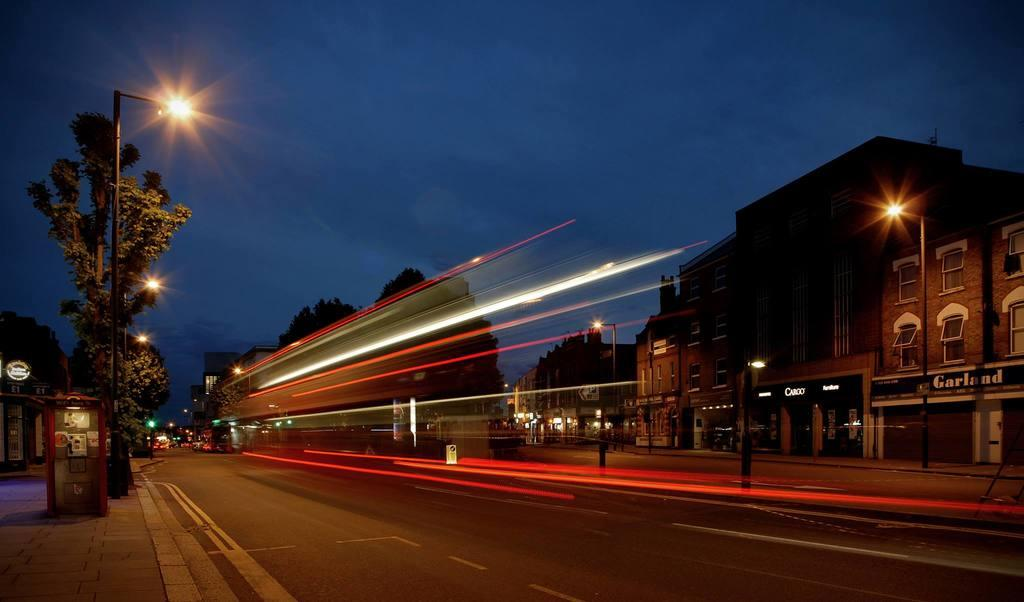What type of structures can be seen in the image? There are buildings in the image. What is the primary mode of transportation depicted in the image? There is a road in the image, which suggests that vehicles might be used for transportation. What type of vegetation is present in the image? There are trees in the image. What signage is visible in the image? Name boards and light boards are present in the image. What type of infrastructure is present in the image? Poles and lights are present in the image. What can be seen in the background of the image? The sky is visible in the background of the image. Can you tell me how many veins are visible in the image? There are no veins present in the image; it features buildings, a road, trees, name boards, light boards, poles, lights, and the sky. What type of servant is shown working in the image? There is no servant present in the image. 